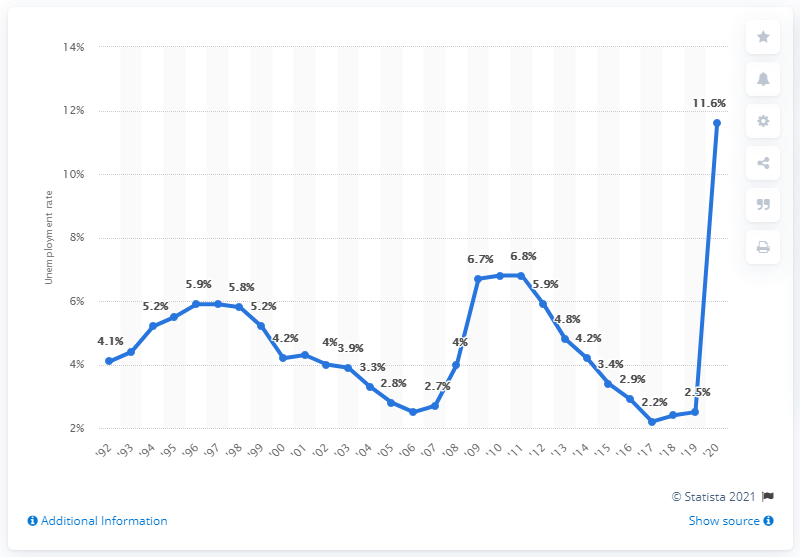Mention a couple of crucial points in this snapshot. In 2020, Hawaii's unemployment rate was 11.6%. 